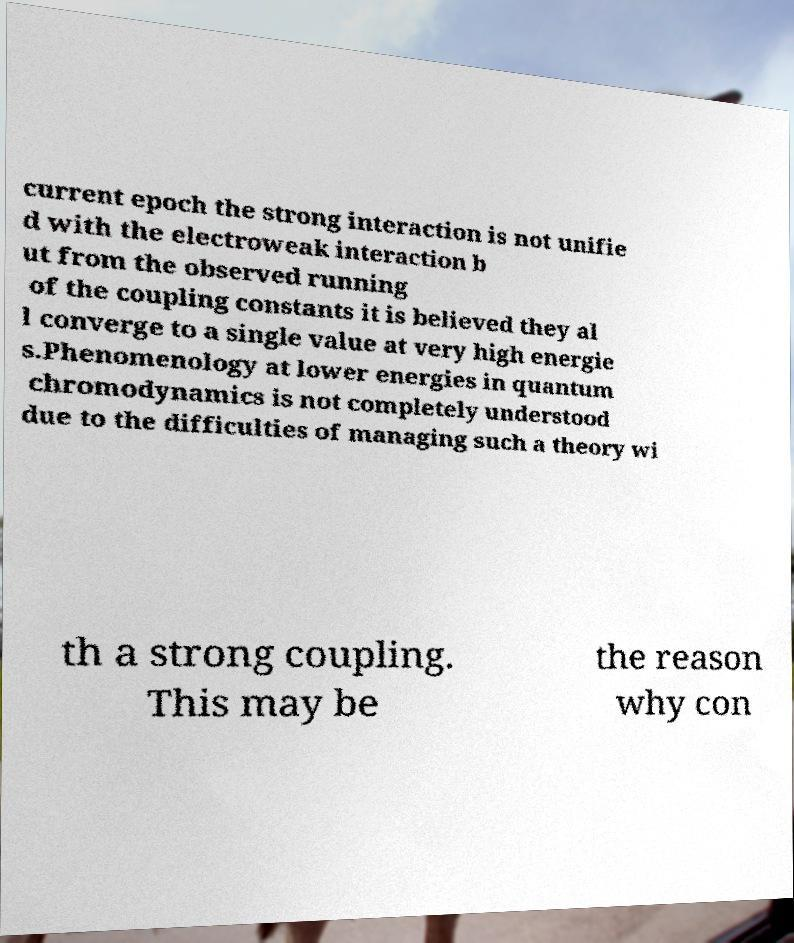What messages or text are displayed in this image? I need them in a readable, typed format. current epoch the strong interaction is not unifie d with the electroweak interaction b ut from the observed running of the coupling constants it is believed they al l converge to a single value at very high energie s.Phenomenology at lower energies in quantum chromodynamics is not completely understood due to the difficulties of managing such a theory wi th a strong coupling. This may be the reason why con 